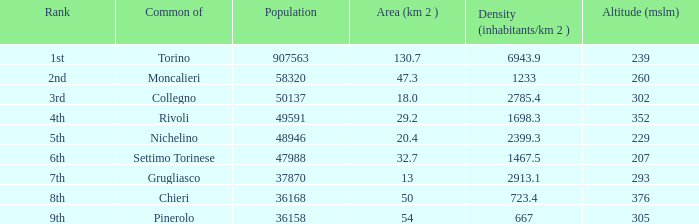What is the density of the common with an area of 20.4 km^2? 2399.3. 